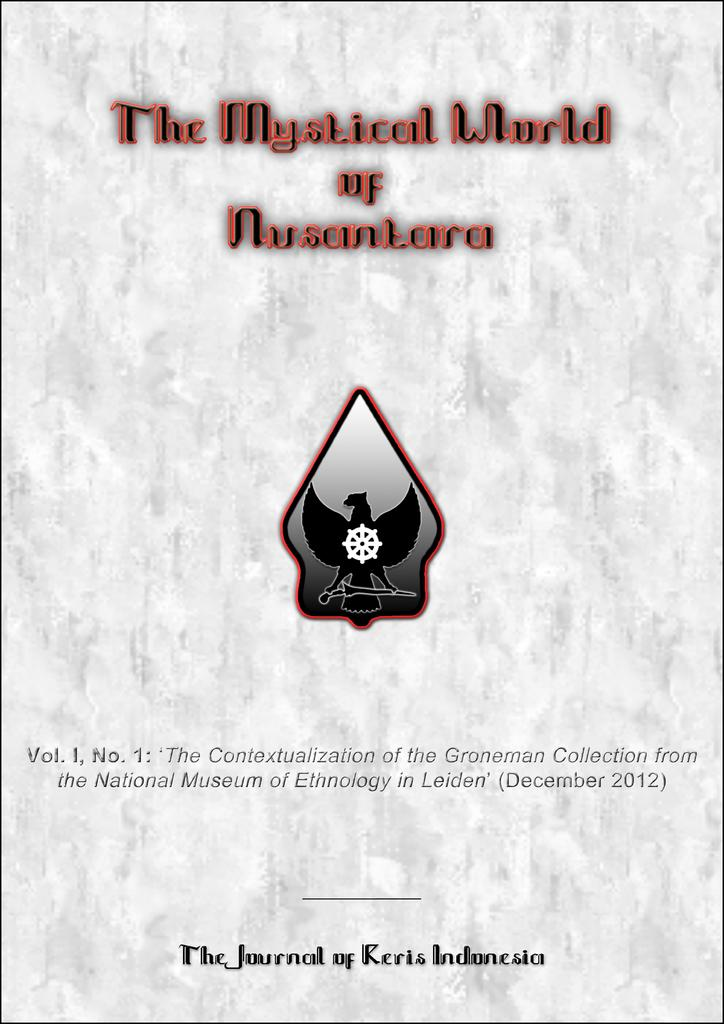<image>
Present a compact description of the photo's key features. The cover of the Journal of Keris Indonesia called The Magical World of Nusantara. 